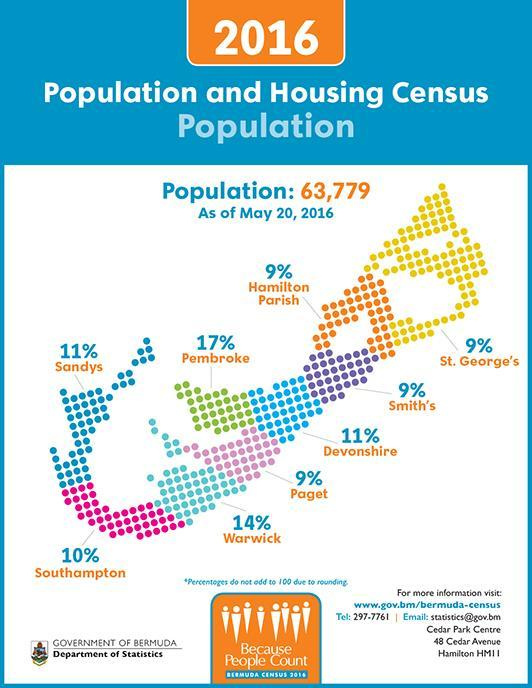Which province/state in Bermuda has the second-highest housing percentage as of May 20, 2016?
Answer the question with a short phrase. Warwick How many provinces/states are in Bermuda? 9 Which province/state in Bermuda has the highest housing percentage as of May 20, 2016? Pembroke 